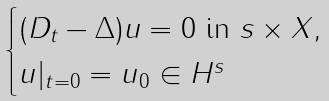<formula> <loc_0><loc_0><loc_500><loc_500>\begin{cases} ( D _ { t } - \Delta ) u = 0 \text { in } \real s \times X , \\ u | _ { t = 0 } = u _ { 0 } \in H ^ { s } \end{cases}</formula> 